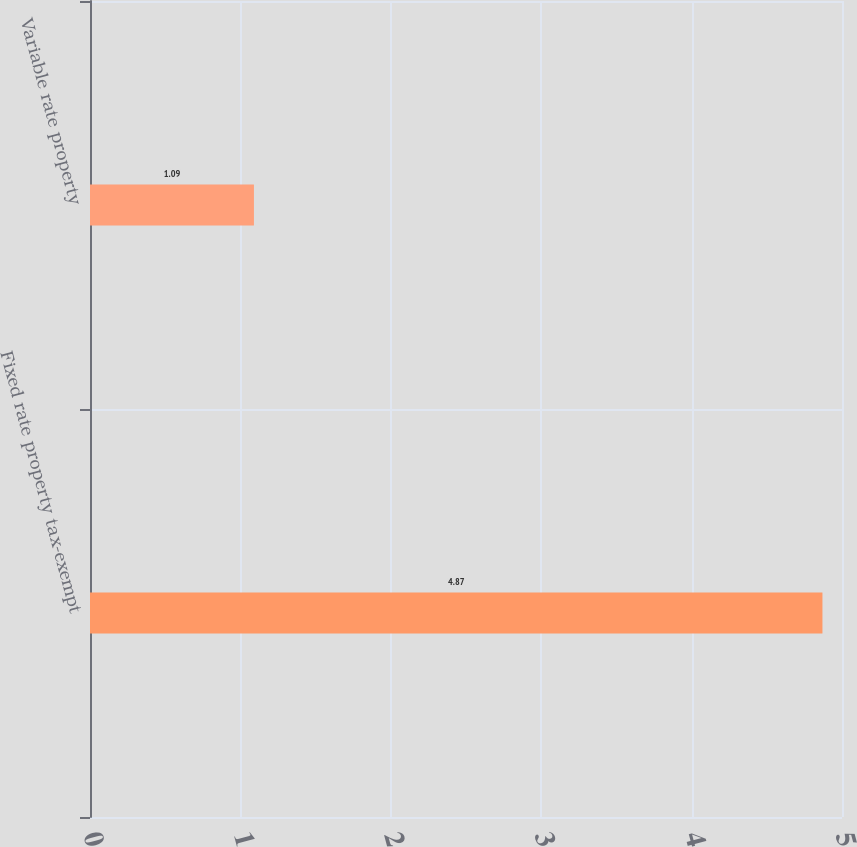Convert chart to OTSL. <chart><loc_0><loc_0><loc_500><loc_500><bar_chart><fcel>Fixed rate property tax-exempt<fcel>Variable rate property<nl><fcel>4.87<fcel>1.09<nl></chart> 